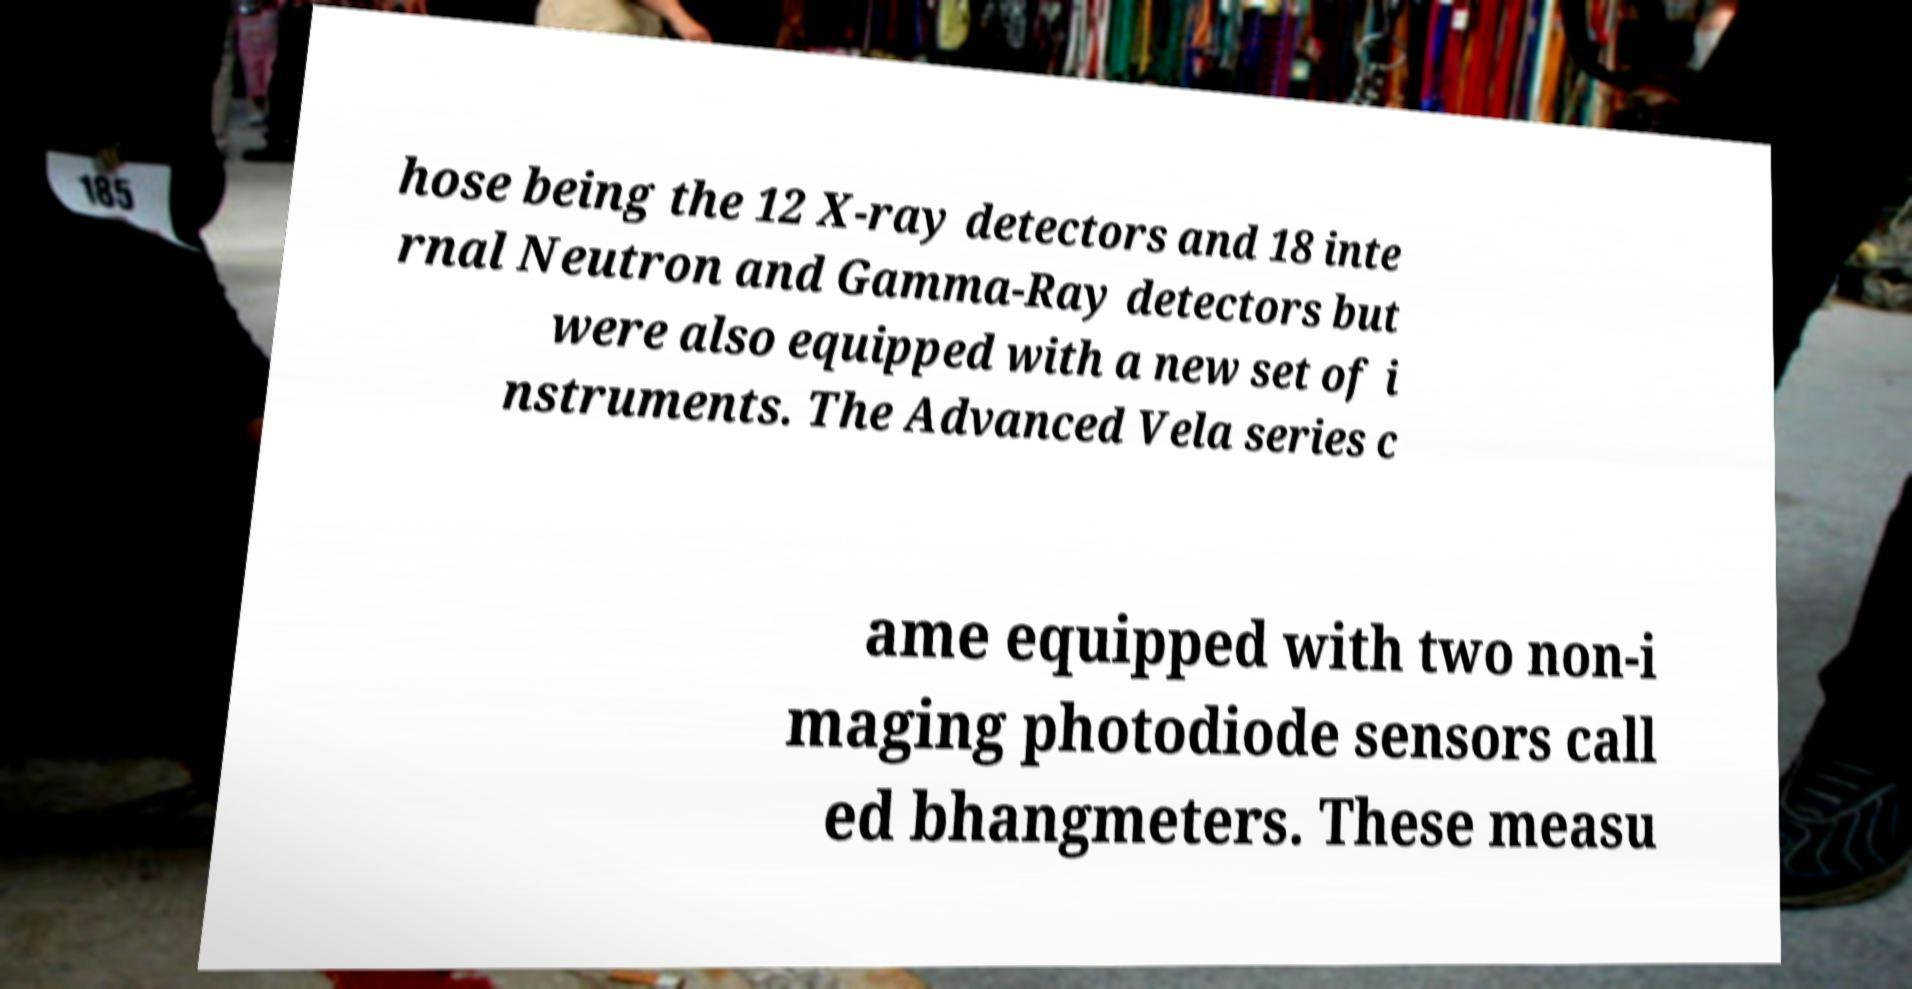Could you extract and type out the text from this image? hose being the 12 X-ray detectors and 18 inte rnal Neutron and Gamma-Ray detectors but were also equipped with a new set of i nstruments. The Advanced Vela series c ame equipped with two non-i maging photodiode sensors call ed bhangmeters. These measu 